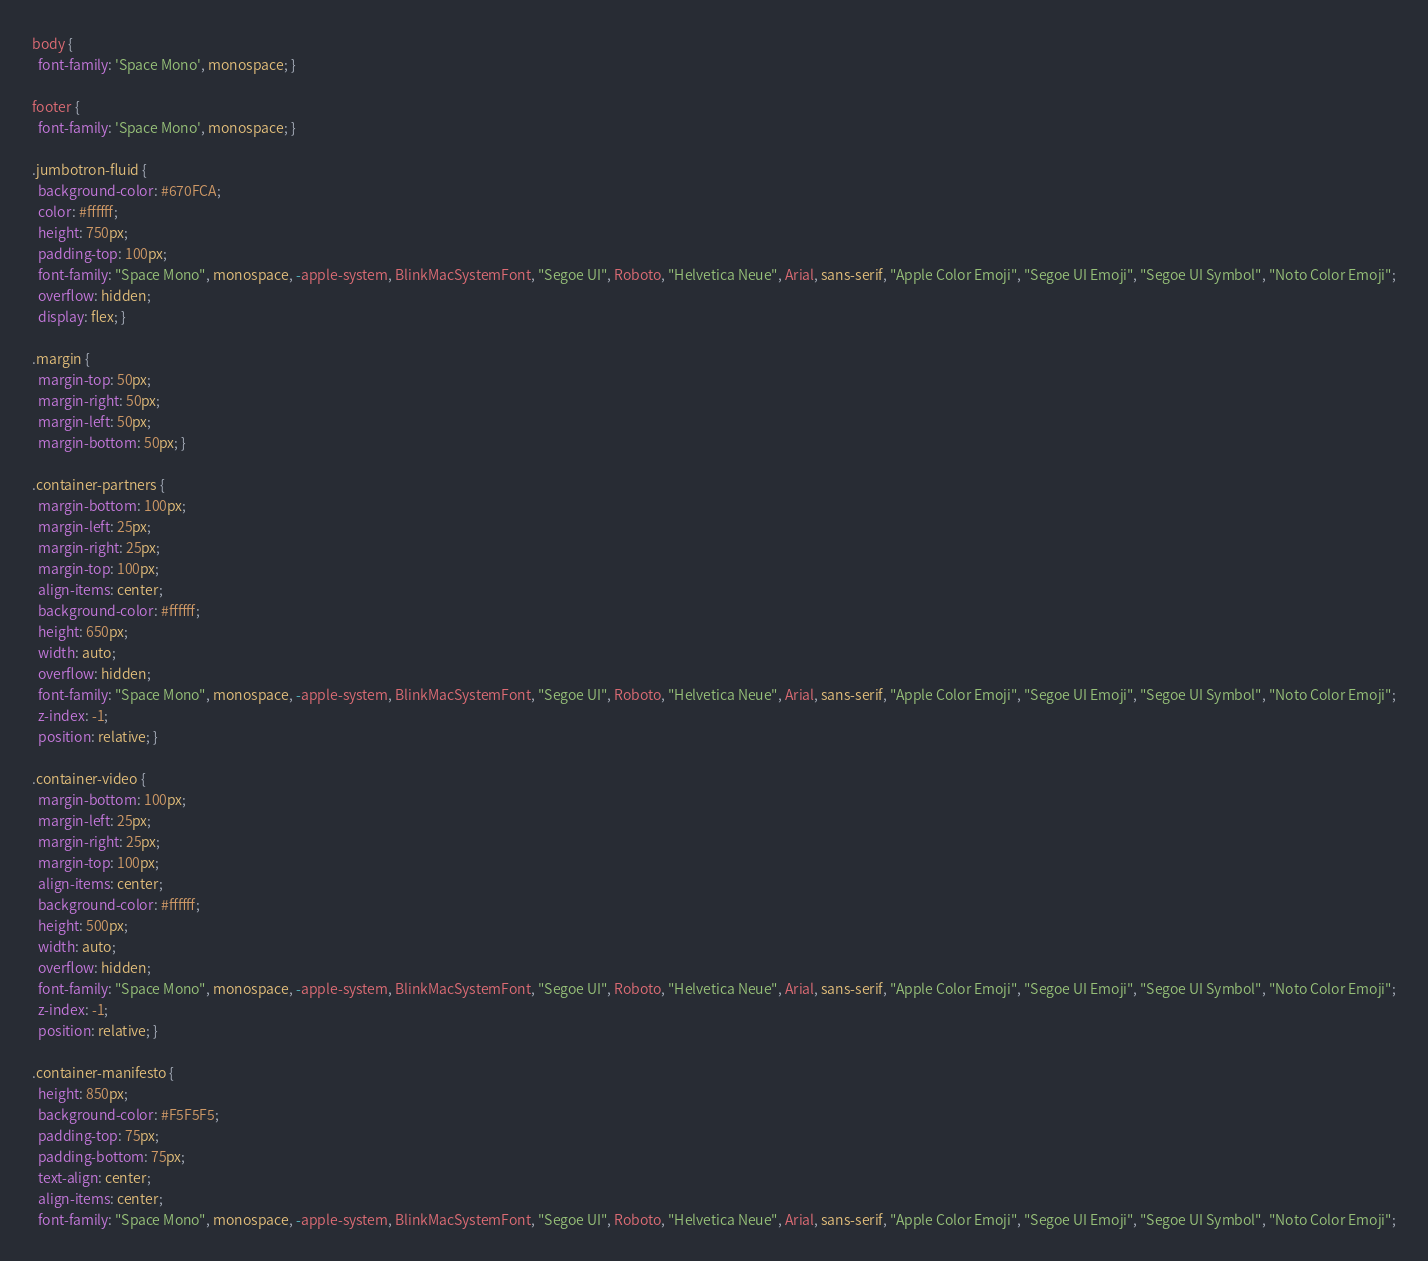<code> <loc_0><loc_0><loc_500><loc_500><_CSS_>body {
  font-family: 'Space Mono', monospace; }

footer {
  font-family: 'Space Mono', monospace; }

.jumbotron-fluid {
  background-color: #670FCA;
  color: #ffffff;
  height: 750px;
  padding-top: 100px;
  font-family: "Space Mono", monospace, -apple-system, BlinkMacSystemFont, "Segoe UI", Roboto, "Helvetica Neue", Arial, sans-serif, "Apple Color Emoji", "Segoe UI Emoji", "Segoe UI Symbol", "Noto Color Emoji";
  overflow: hidden;
  display: flex; }

.margin {
  margin-top: 50px;
  margin-right: 50px;
  margin-left: 50px;
  margin-bottom: 50px; }

.container-partners {
  margin-bottom: 100px;
  margin-left: 25px;
  margin-right: 25px;
  margin-top: 100px;
  align-items: center;
  background-color: #ffffff;
  height: 650px;
  width: auto;
  overflow: hidden;
  font-family: "Space Mono", monospace, -apple-system, BlinkMacSystemFont, "Segoe UI", Roboto, "Helvetica Neue", Arial, sans-serif, "Apple Color Emoji", "Segoe UI Emoji", "Segoe UI Symbol", "Noto Color Emoji";
  z-index: -1;
  position: relative; }

.container-video {
  margin-bottom: 100px;
  margin-left: 25px;
  margin-right: 25px;
  margin-top: 100px;
  align-items: center;
  background-color: #ffffff;
  height: 500px;
  width: auto;
  overflow: hidden;
  font-family: "Space Mono", monospace, -apple-system, BlinkMacSystemFont, "Segoe UI", Roboto, "Helvetica Neue", Arial, sans-serif, "Apple Color Emoji", "Segoe UI Emoji", "Segoe UI Symbol", "Noto Color Emoji";
  z-index: -1;
  position: relative; }

.container-manifesto {
  height: 850px;
  background-color: #F5F5F5;
  padding-top: 75px;
  padding-bottom: 75px;
  text-align: center;
  align-items: center;
  font-family: "Space Mono", monospace, -apple-system, BlinkMacSystemFont, "Segoe UI", Roboto, "Helvetica Neue", Arial, sans-serif, "Apple Color Emoji", "Segoe UI Emoji", "Segoe UI Symbol", "Noto Color Emoji";</code> 